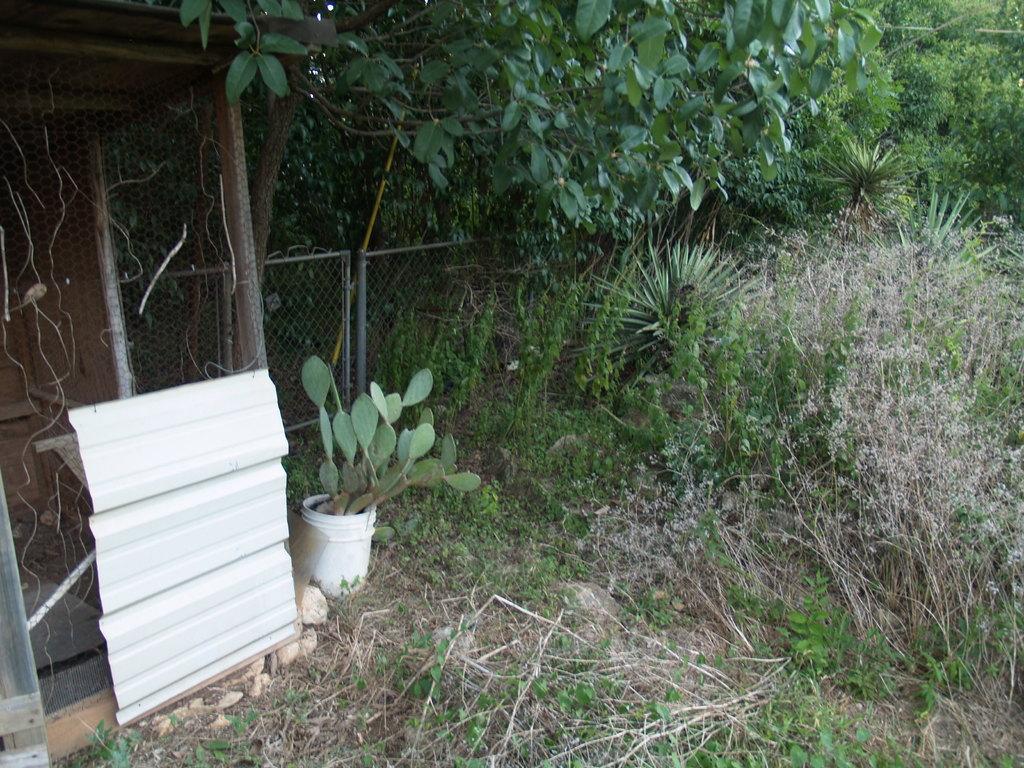In one or two sentences, can you explain what this image depicts? In the image we can see grass, fence, cactus plant in the bucket, trees and white sheet. 